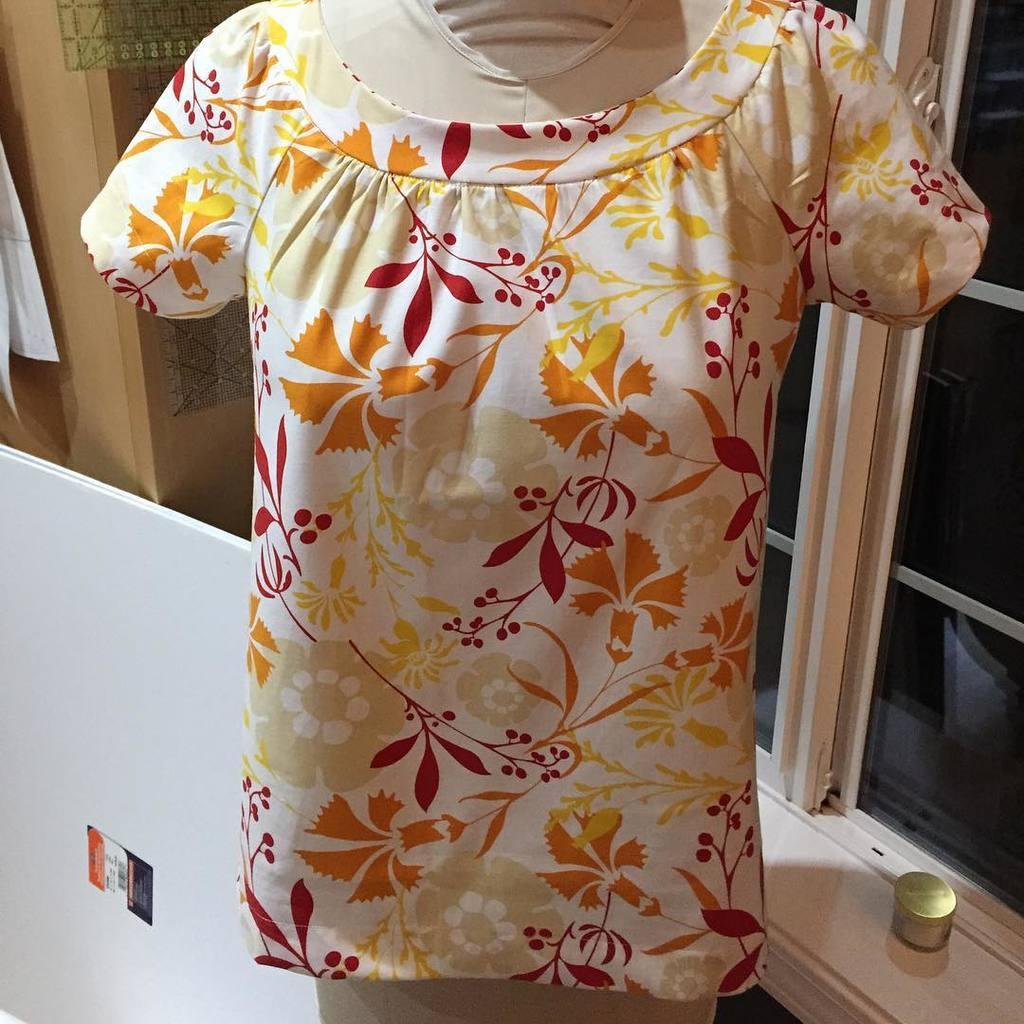Please provide a concise description of this image. In this picture I can see a dress in front which is of white, yellow, orange and red in color. Behind it I see a white color thing, windows and a brown color thing. 